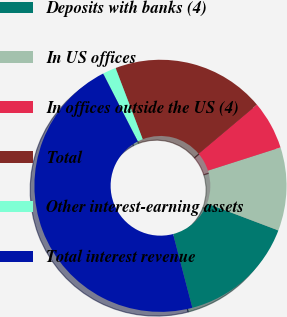Convert chart to OTSL. <chart><loc_0><loc_0><loc_500><loc_500><pie_chart><fcel>Deposits with banks (4)<fcel>In US offices<fcel>In offices outside the US (4)<fcel>Total<fcel>Other interest-earning assets<fcel>Total interest revenue<nl><fcel>15.17%<fcel>10.69%<fcel>6.21%<fcel>19.66%<fcel>1.72%<fcel>46.56%<nl></chart> 